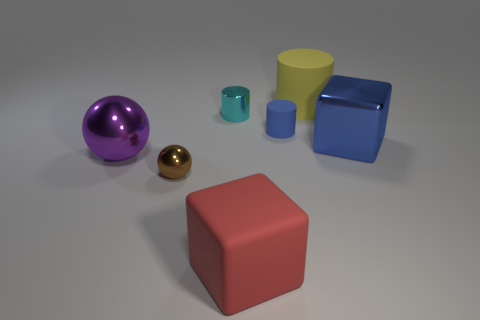How many other things are the same color as the tiny shiny ball? None of the objects in the image share the same color with the tiny shiny gold ball. 